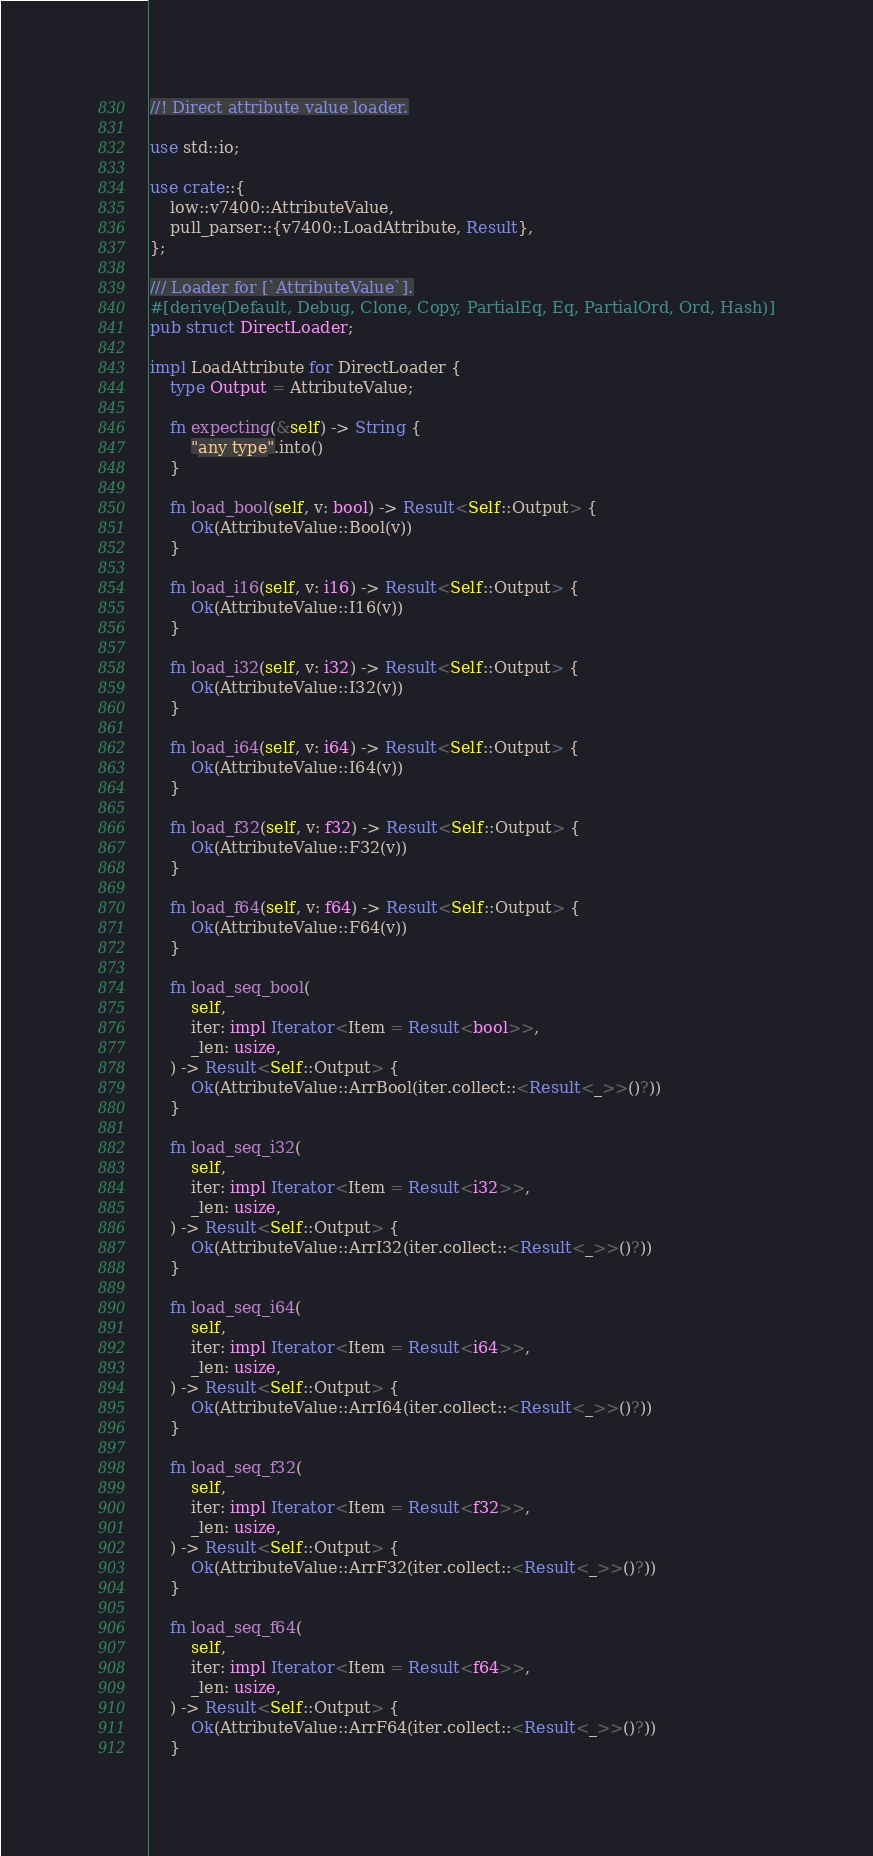<code> <loc_0><loc_0><loc_500><loc_500><_Rust_>//! Direct attribute value loader.

use std::io;

use crate::{
    low::v7400::AttributeValue,
    pull_parser::{v7400::LoadAttribute, Result},
};

/// Loader for [`AttributeValue`].
#[derive(Default, Debug, Clone, Copy, PartialEq, Eq, PartialOrd, Ord, Hash)]
pub struct DirectLoader;

impl LoadAttribute for DirectLoader {
    type Output = AttributeValue;

    fn expecting(&self) -> String {
        "any type".into()
    }

    fn load_bool(self, v: bool) -> Result<Self::Output> {
        Ok(AttributeValue::Bool(v))
    }

    fn load_i16(self, v: i16) -> Result<Self::Output> {
        Ok(AttributeValue::I16(v))
    }

    fn load_i32(self, v: i32) -> Result<Self::Output> {
        Ok(AttributeValue::I32(v))
    }

    fn load_i64(self, v: i64) -> Result<Self::Output> {
        Ok(AttributeValue::I64(v))
    }

    fn load_f32(self, v: f32) -> Result<Self::Output> {
        Ok(AttributeValue::F32(v))
    }

    fn load_f64(self, v: f64) -> Result<Self::Output> {
        Ok(AttributeValue::F64(v))
    }

    fn load_seq_bool(
        self,
        iter: impl Iterator<Item = Result<bool>>,
        _len: usize,
    ) -> Result<Self::Output> {
        Ok(AttributeValue::ArrBool(iter.collect::<Result<_>>()?))
    }

    fn load_seq_i32(
        self,
        iter: impl Iterator<Item = Result<i32>>,
        _len: usize,
    ) -> Result<Self::Output> {
        Ok(AttributeValue::ArrI32(iter.collect::<Result<_>>()?))
    }

    fn load_seq_i64(
        self,
        iter: impl Iterator<Item = Result<i64>>,
        _len: usize,
    ) -> Result<Self::Output> {
        Ok(AttributeValue::ArrI64(iter.collect::<Result<_>>()?))
    }

    fn load_seq_f32(
        self,
        iter: impl Iterator<Item = Result<f32>>,
        _len: usize,
    ) -> Result<Self::Output> {
        Ok(AttributeValue::ArrF32(iter.collect::<Result<_>>()?))
    }

    fn load_seq_f64(
        self,
        iter: impl Iterator<Item = Result<f64>>,
        _len: usize,
    ) -> Result<Self::Output> {
        Ok(AttributeValue::ArrF64(iter.collect::<Result<_>>()?))
    }
</code> 